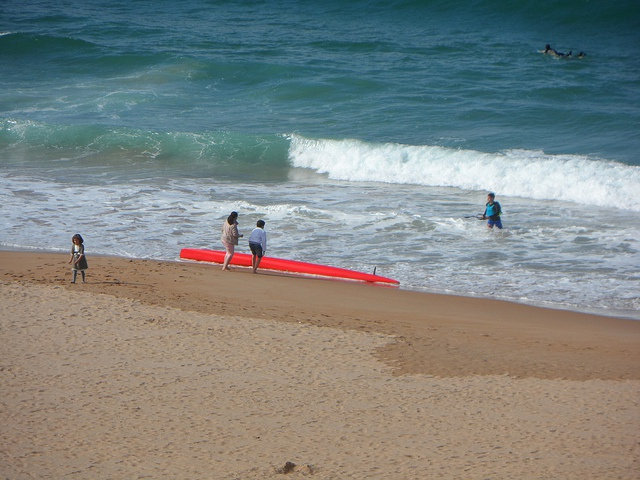Describe the objects in this image and their specific colors. I can see surfboard in darkblue, red, salmon, and darkgray tones, boat in darkblue, red, salmon, and brown tones, people in darkblue, gray, darkgray, and black tones, people in darkblue, black, gray, and darkgray tones, and people in darkblue, black, gray, and maroon tones in this image. 